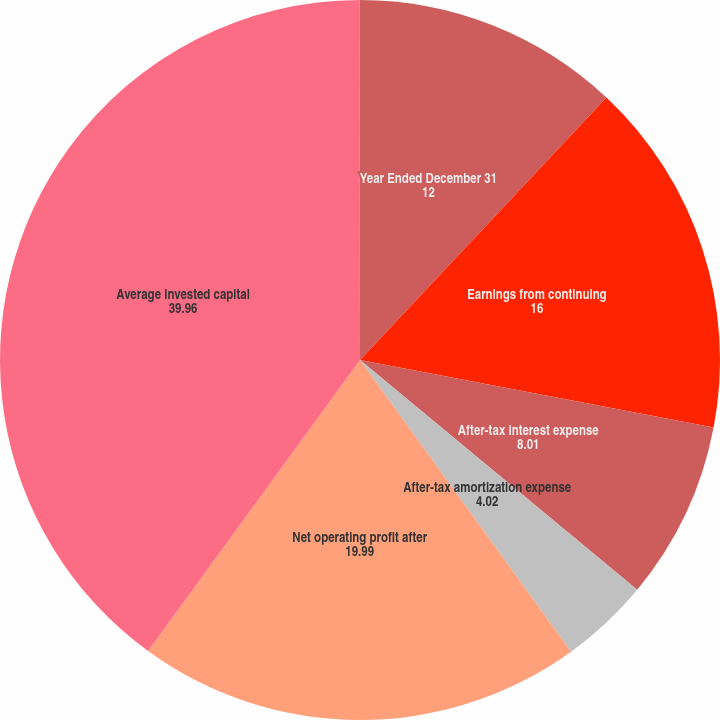<chart> <loc_0><loc_0><loc_500><loc_500><pie_chart><fcel>Year Ended December 31<fcel>Earnings from continuing<fcel>After-tax interest expense<fcel>After-tax amortization expense<fcel>Net operating profit after<fcel>Average invested capital<fcel>Return on invested capital<nl><fcel>12.0%<fcel>16.0%<fcel>8.01%<fcel>4.02%<fcel>19.99%<fcel>39.96%<fcel>0.02%<nl></chart> 